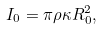<formula> <loc_0><loc_0><loc_500><loc_500>I _ { 0 } = \pi \rho \kappa R _ { 0 } ^ { 2 } ,</formula> 